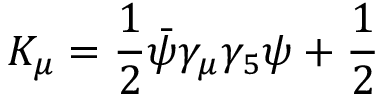Convert formula to latex. <formula><loc_0><loc_0><loc_500><loc_500>K _ { \mu } = \frac { 1 } { 2 } \bar { \psi } \gamma _ { \mu } \gamma _ { 5 } \psi + \frac { 1 } { 2 }</formula> 